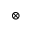Convert formula to latex. <formula><loc_0><loc_0><loc_500><loc_500>\otimes</formula> 